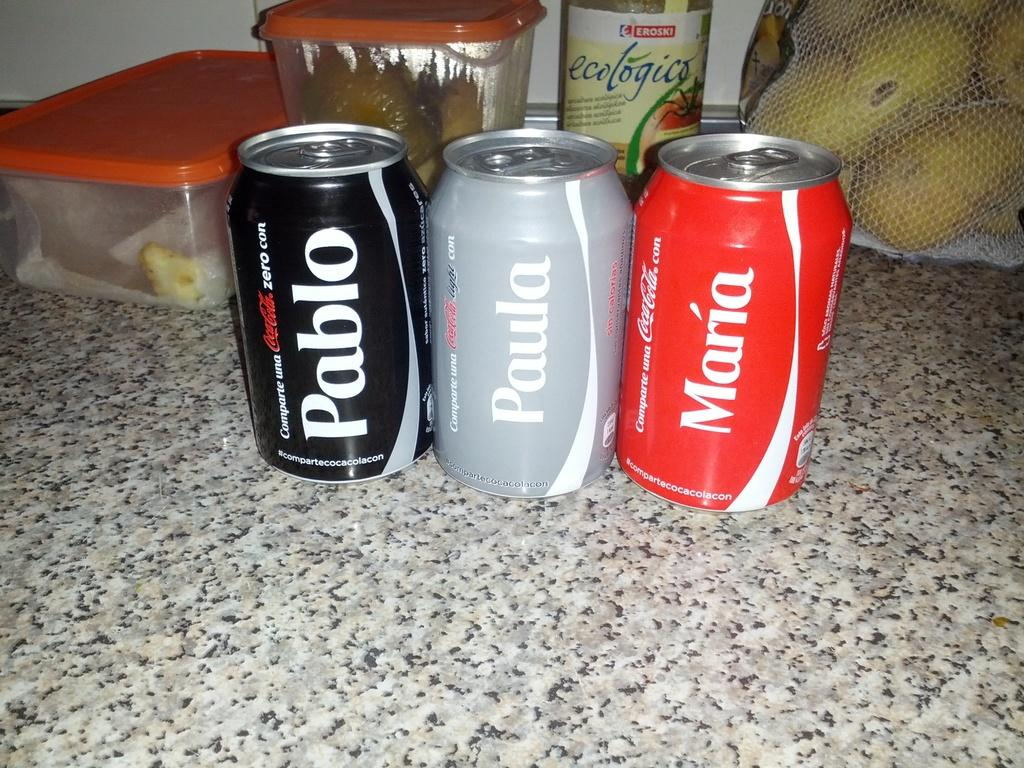<image>
Provide a brief description of the given image. Three cans of CocaCola with Pablo, Paula, and Maria on them. 